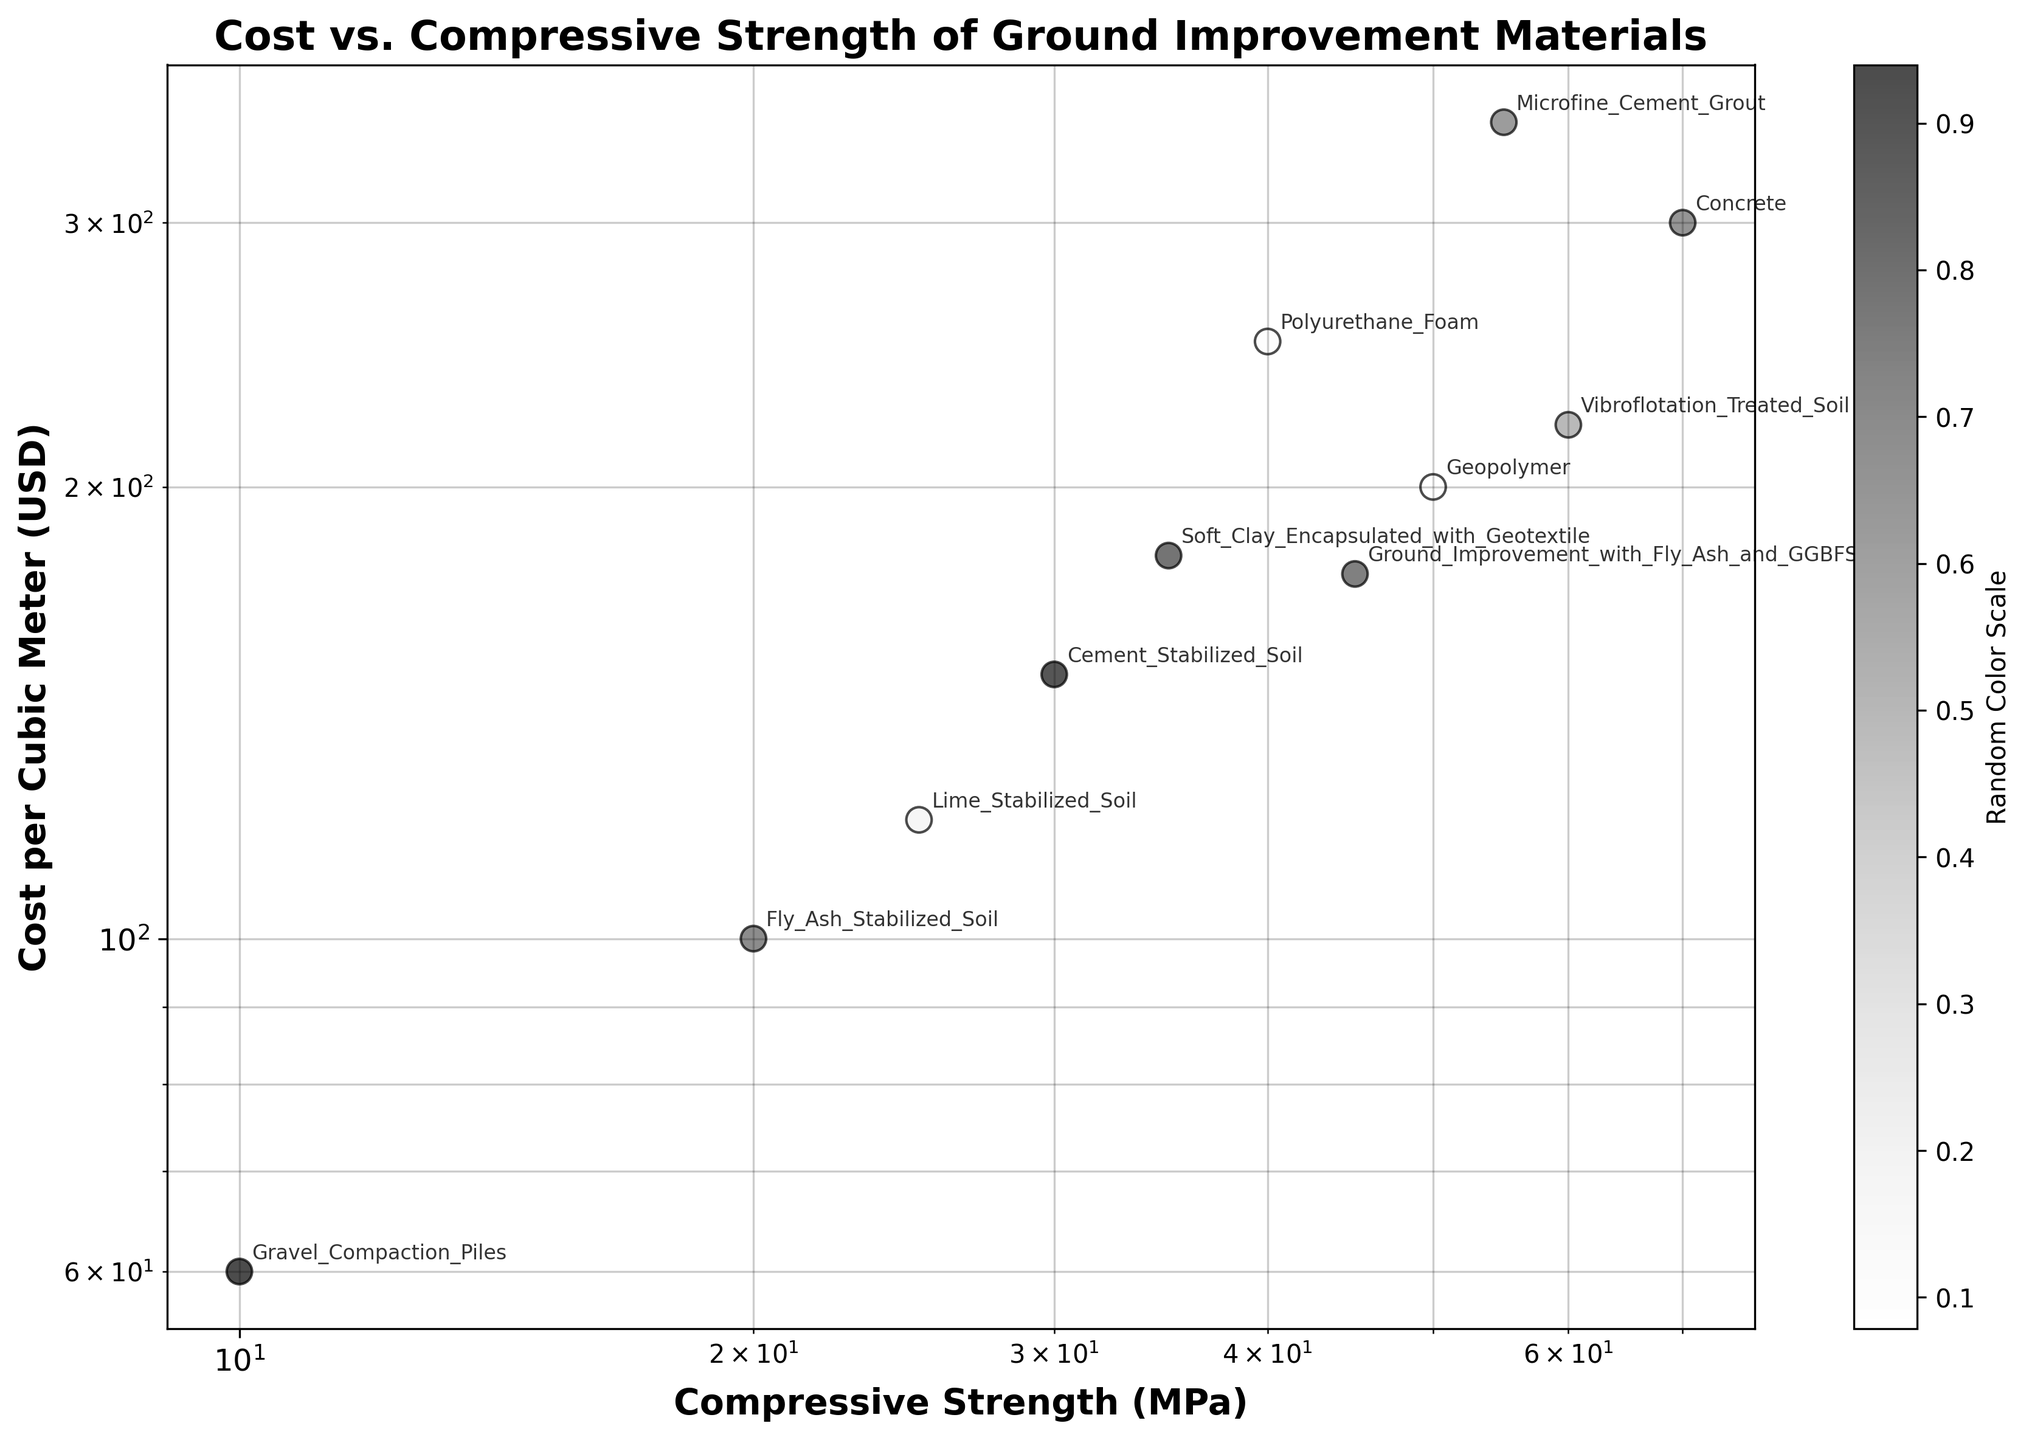Which material has the highest compressive strength? Look for the data point that is farthest to the right on the x-axis of the scatter plot. The material is "Concrete" with a compressive strength of 70 MPa.
Answer: Concrete What is the cost per cubic meter of the material with the lowest compressive strength? Identify the data point that is farthest to the left on the x-axis. The material "Gravel_Compaction_Piles" has a compressive strength of 10 MPa. The corresponding cost is $60 per cubic meter.
Answer: $60 Between Geopolymer and Microfine Cement Grout, which one is more cost-effective in terms of compressive strength and cost ratio? Compute the ratio of compressive strength to cost for both materials. For Geopolymer: 50 MPa / $200 = 0.25 MPa/USD. For Microfine Cement Grout: 55 MPa / $350 = 0.157 MPa/USD. Geopolymer has a higher compressive strength to cost ratio.
Answer: Geopolymer Which materials fall into the same cost range near $200 per cubic meter? Check the scatter plot for data points close to the cost axis at $200. Geopolymer, Soft_Clay_Encapsulated_with_Geotextile, and Vibroflotation_Treated_Soil are the materials.
Answer: Geopolymer, Soft_Clay_Encapsulated_with_Geotextile, Vibroflotation_Treated_Soil What is the relationship between cost and compressive strength in this dataset? Observe the trend of data points. There is a general positive correlation where higher compressive strength generally corresponds to higher cost.
Answer: Positive correlation How does the compressive strength of Fly Ash Stabilized Soil compare to Lime Stabilized Soil? Locate both materials and compare their positions on the x-axis. Fly_Ash_Stabilized_Soil has a compressive strength of 20 MPa while Lime_Stabilized_Soil has 25 MPa.
Answer: Lime_Stabilized_Soil is stronger What is the median value of compressive strength for these materials? Arrange all compressive strengths in ascending order: 10, 20, 25, 30, 35, 40, 45, 50, 55, 60, 70 MPa. The median value is the middle one: 40 MPa.
Answer: 40 MPa Which material appears most cost-effective considering both high compressive strength and low cost? Evaluate the materials with higher compressive strength and their corresponding cost. Concrete has the highest compressive strength but is very expensive. Geopolymer and Vibroflotation_Treated_Soil have high compressive strengths with relatively lower costs around $200.
Answer: Geopolymer or Vibroflotation_Treated_Soil 